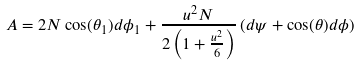Convert formula to latex. <formula><loc_0><loc_0><loc_500><loc_500>A = 2 N \cos ( \theta _ { 1 } ) d \phi _ { 1 } + \frac { u ^ { 2 } N } { 2 \left ( 1 + \frac { u ^ { 2 } } { 6 } \right ) } \left ( d \psi + \cos ( \theta ) d \phi \right )</formula> 